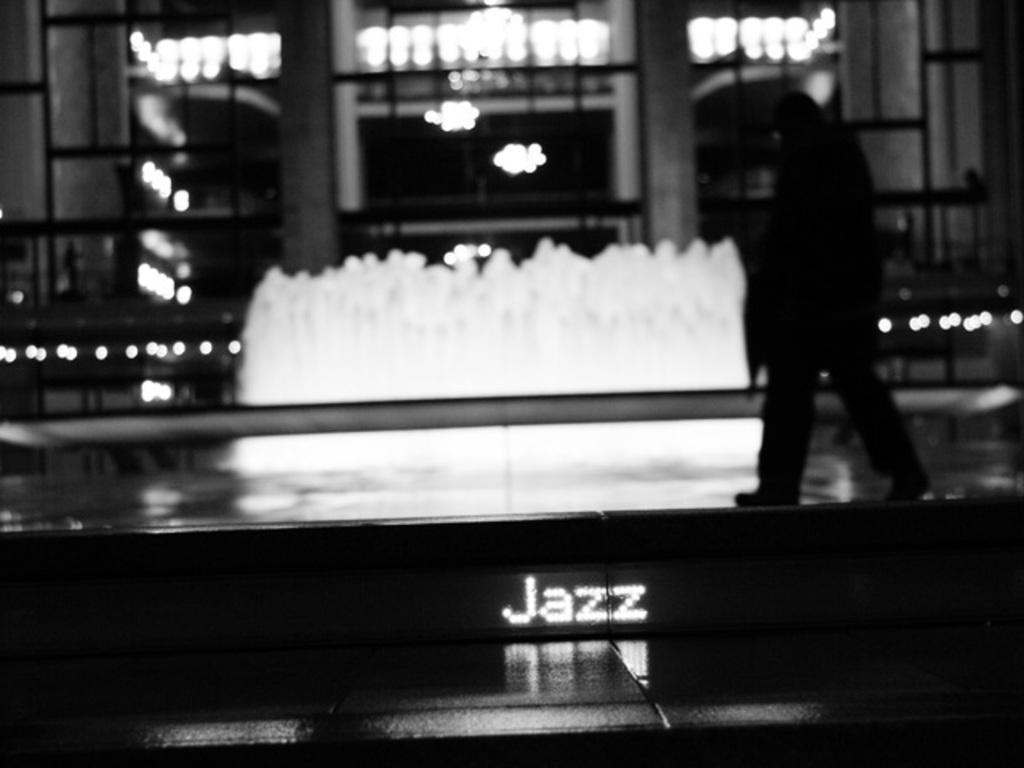What is the color scheme of the image? The image is black and white. What else can be seen in the image besides the person in the foreground? There is text and a building in the background of the image. Can you describe the lighting in the image? There is light visible in the background of the image. What type of copper plant can be seen in the image? There is no copper plant present in the image. Is there a spy visible in the image? There is no indication of a spy in the image. 